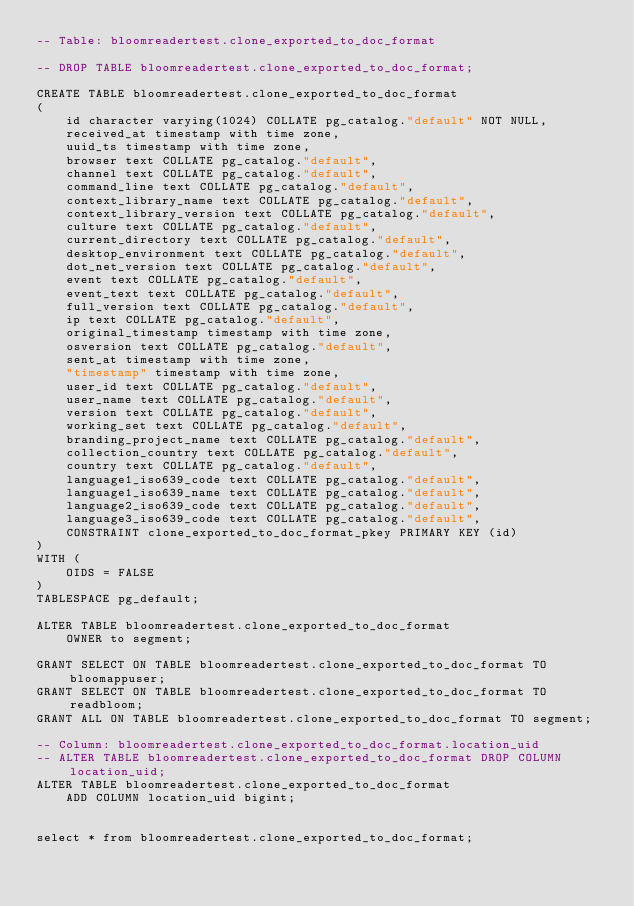<code> <loc_0><loc_0><loc_500><loc_500><_SQL_>-- Table: bloomreadertest.clone_exported_to_doc_format

-- DROP TABLE bloomreadertest.clone_exported_to_doc_format;

CREATE TABLE bloomreadertest.clone_exported_to_doc_format
(
    id character varying(1024) COLLATE pg_catalog."default" NOT NULL,
    received_at timestamp with time zone,
    uuid_ts timestamp with time zone,
    browser text COLLATE pg_catalog."default",
    channel text COLLATE pg_catalog."default",
    command_line text COLLATE pg_catalog."default",
    context_library_name text COLLATE pg_catalog."default",
    context_library_version text COLLATE pg_catalog."default",
    culture text COLLATE pg_catalog."default",
    current_directory text COLLATE pg_catalog."default",
    desktop_environment text COLLATE pg_catalog."default",
    dot_net_version text COLLATE pg_catalog."default",
    event text COLLATE pg_catalog."default",
    event_text text COLLATE pg_catalog."default",
    full_version text COLLATE pg_catalog."default",
    ip text COLLATE pg_catalog."default",
    original_timestamp timestamp with time zone,
    osversion text COLLATE pg_catalog."default",
    sent_at timestamp with time zone,
    "timestamp" timestamp with time zone,
    user_id text COLLATE pg_catalog."default",
    user_name text COLLATE pg_catalog."default",
    version text COLLATE pg_catalog."default",
    working_set text COLLATE pg_catalog."default",
    branding_project_name text COLLATE pg_catalog."default",
    collection_country text COLLATE pg_catalog."default",
    country text COLLATE pg_catalog."default",
    language1_iso639_code text COLLATE pg_catalog."default",
    language1_iso639_name text COLLATE pg_catalog."default",
    language2_iso639_code text COLLATE pg_catalog."default",
    language3_iso639_code text COLLATE pg_catalog."default",
    CONSTRAINT clone_exported_to_doc_format_pkey PRIMARY KEY (id)
)
WITH (
    OIDS = FALSE
)
TABLESPACE pg_default;

ALTER TABLE bloomreadertest.clone_exported_to_doc_format
    OWNER to segment;

GRANT SELECT ON TABLE bloomreadertest.clone_exported_to_doc_format TO bloomappuser;
GRANT SELECT ON TABLE bloomreadertest.clone_exported_to_doc_format TO readbloom;
GRANT ALL ON TABLE bloomreadertest.clone_exported_to_doc_format TO segment;

-- Column: bloomreadertest.clone_exported_to_doc_format.location_uid
-- ALTER TABLE bloomreadertest.clone_exported_to_doc_format DROP COLUMN location_uid;
ALTER TABLE bloomreadertest.clone_exported_to_doc_format
    ADD COLUMN location_uid bigint;	
	
	
select * from bloomreadertest.clone_exported_to_doc_format;</code> 